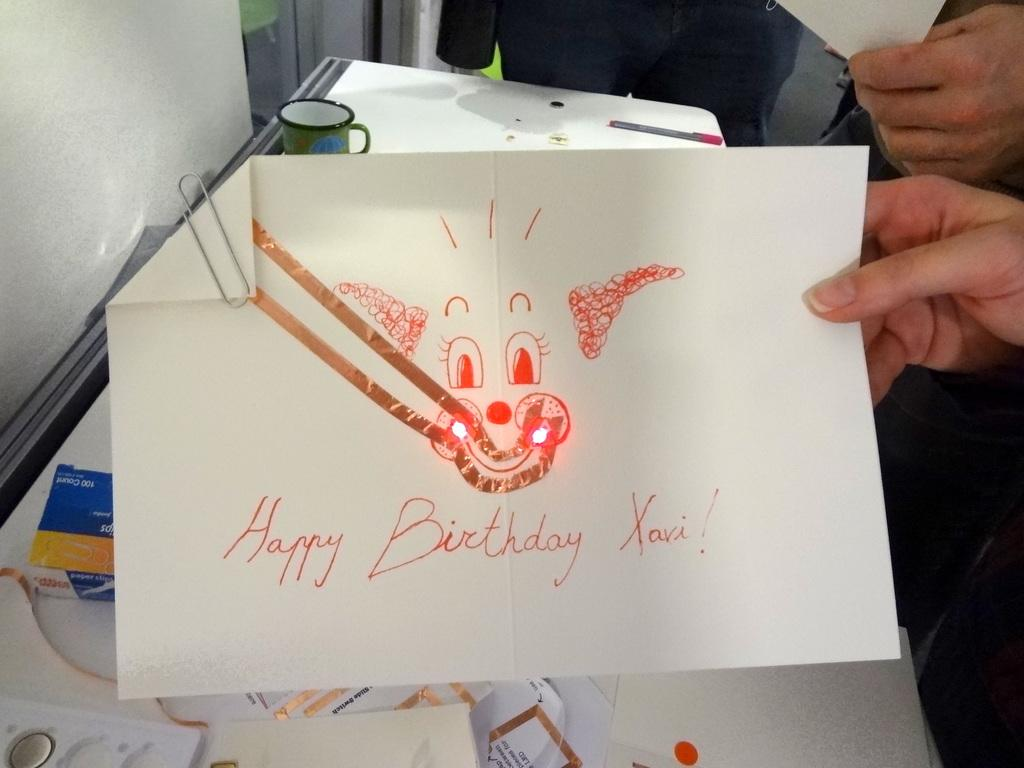Who or what is present in the image? There are people in the image. What are the people holding in their hands? The people are holding papers in their hands. What can be seen in the background of the image? There is a wall in the background of the image. What furniture is visible in the image? There is a table in the image. What items are on the table? There are papers, a pen, and a cup on the table. What type of jewel is on the table in the image? There is no jewel present on the table in the image. What tax-related information can be found on the papers in the image? The provided facts do not mention any tax-related information on the papers in the image. 